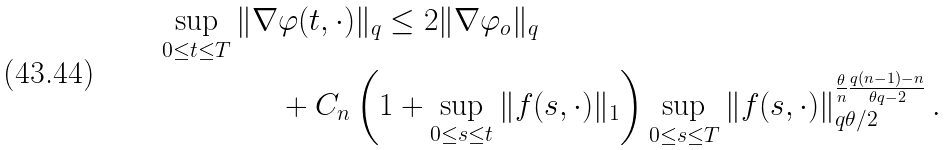<formula> <loc_0><loc_0><loc_500><loc_500>\sup _ { 0 \leq t \leq T } \| \nabla & \varphi ( t , \cdot ) \| _ { q } \leq 2 \| \nabla \varphi _ { o } \| _ { q } \\ & + C _ { n } \left ( 1 + \sup _ { 0 \leq s \leq t } \| f ( s , \cdot ) \| _ { 1 } \right ) \sup _ { 0 \leq s \leq T } \| f ( s , \cdot ) \| ^ { \frac { \theta } { n } \frac { q ( n - 1 ) - n } { \theta q - 2 } } _ { q \theta / 2 } \, .</formula> 